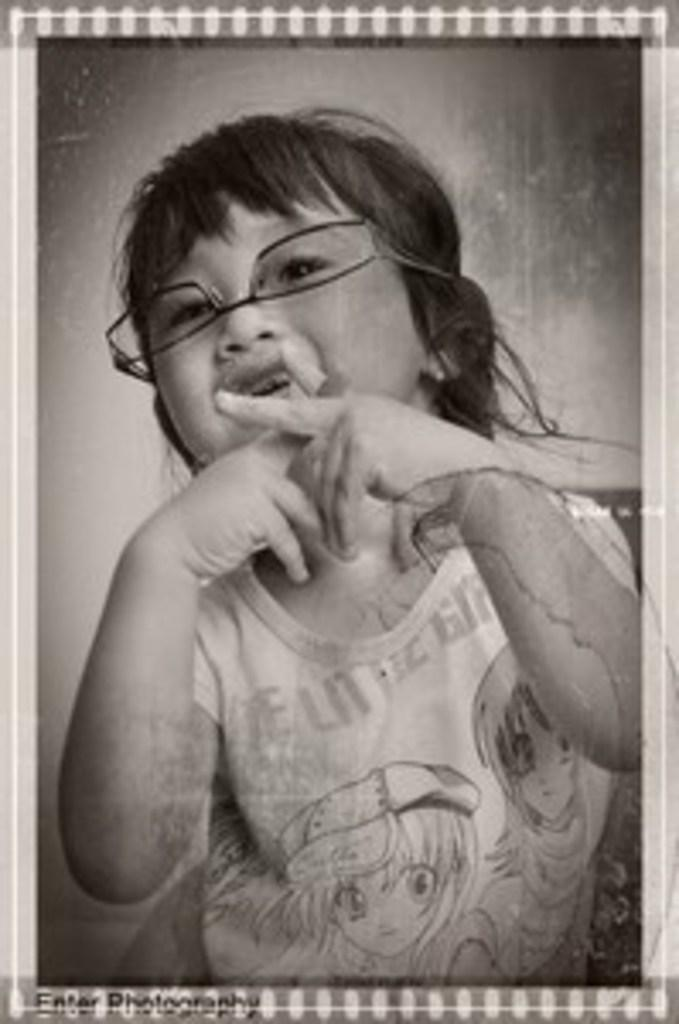What is the color scheme of the image? The image is black and white. Who is the main subject in the image? There is a girl in the image. What accessory is the girl wearing? The girl is wearing spectacles. What type of sweater is the girl wearing in the image? There is no sweater visible in the image, as it is in black and white and the girl is wearing spectacles. 